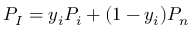Convert formula to latex. <formula><loc_0><loc_0><loc_500><loc_500>P _ { I } = y _ { i } P _ { i } + ( 1 - y _ { i } ) P _ { n }</formula> 